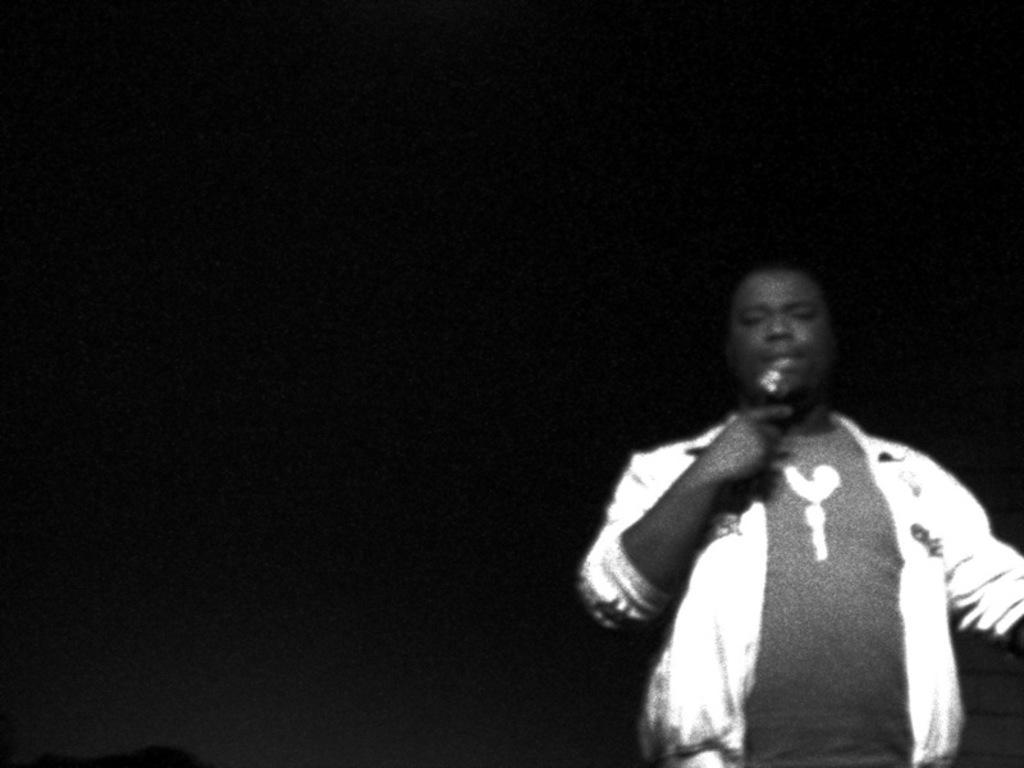In one or two sentences, can you explain what this image depicts? This is a black and white picture. The man on the right side who is wearing a white jacket is holding a microphone in his hand and I think he is talking on the microphone. In the background, it is white in color. 